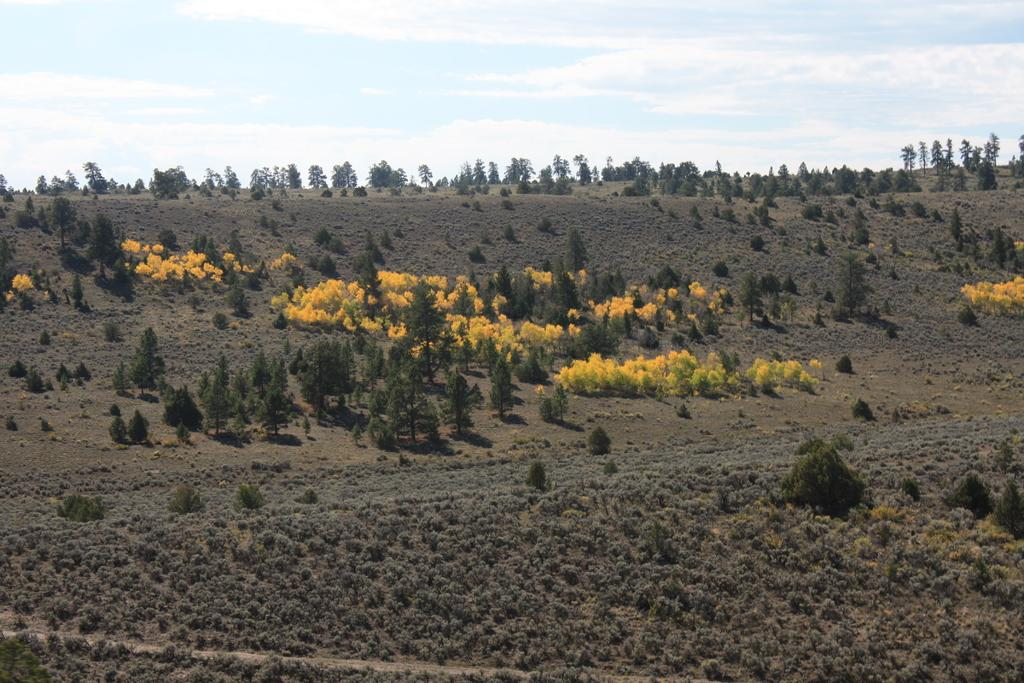What color are the trees in the image? The trees in the image are yellow. Can you describe the size of the trees in the image? There are big trees and small trees in the image. What other types of vegetation can be seen in the image? There are bushes, plants, and grass on the ground in the image. How would you describe the sky in the image? The sky is cloudy in the image. How many sisters are sitting in the library in the image? There are no sisters or library present in the image; it features trees, bushes, plants, grass, and a cloudy sky. What type of plastic objects can be seen in the image? There are no plastic objects present in the image. 